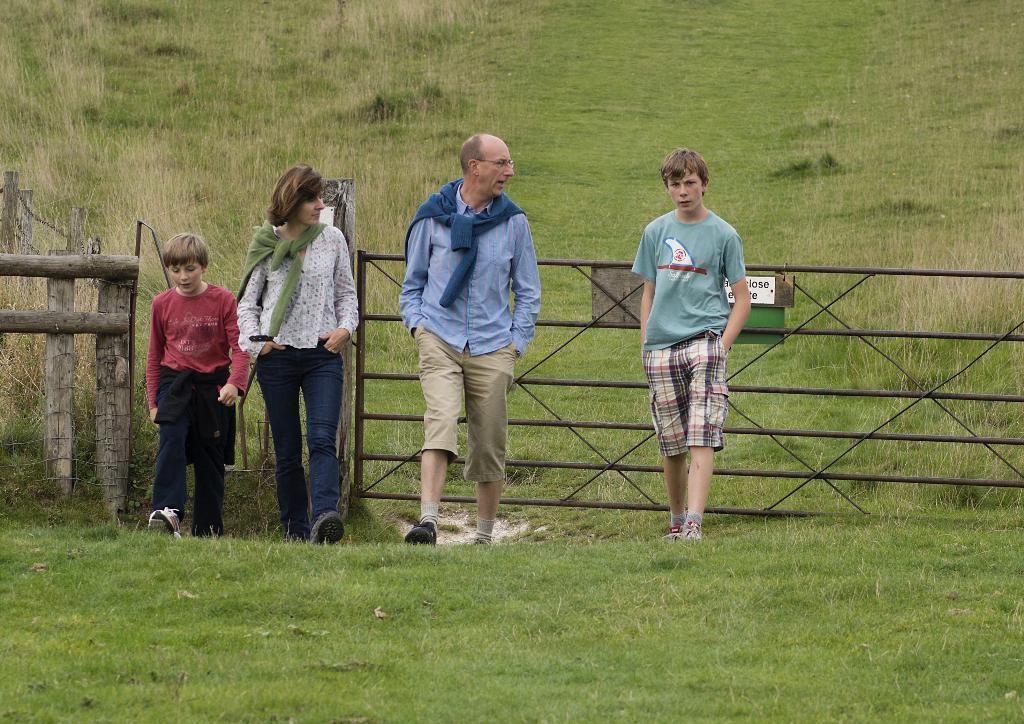Describe this image in one or two sentences. In this image there is a man, woman and two boys standing on a field, behind them there is fencing, in the background there is a field. 